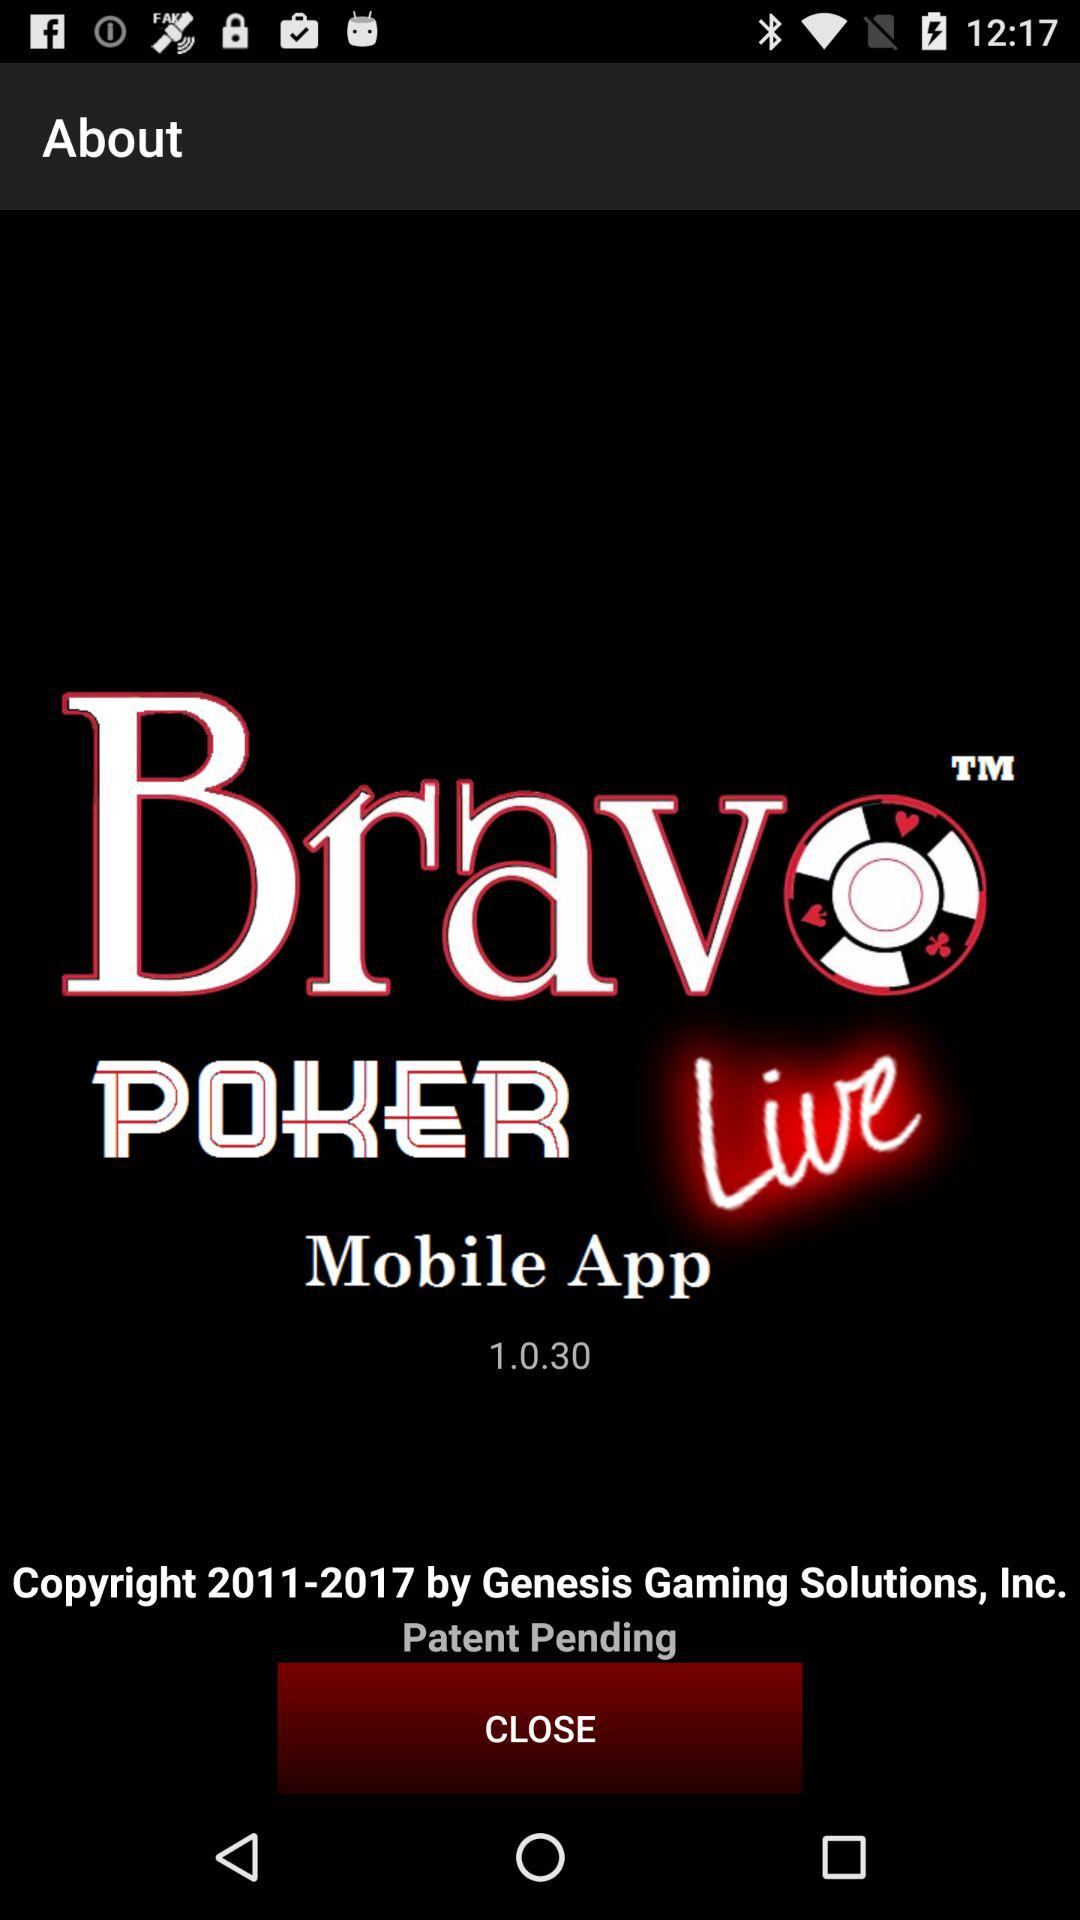Who gave the copyright? The copyright is given by Genesis Gaming Solutions. 